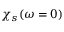Convert formula to latex. <formula><loc_0><loc_0><loc_500><loc_500>\chi _ { s } ( \omega = 0 )</formula> 